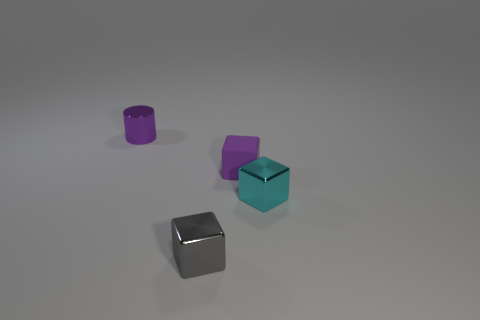Subtract all purple blocks. Subtract all purple cylinders. How many blocks are left? 2 Add 2 large cyan metallic balls. How many objects exist? 6 Subtract all cylinders. How many objects are left? 3 Subtract 0 red cubes. How many objects are left? 4 Subtract all cyan shiny cubes. Subtract all tiny purple blocks. How many objects are left? 2 Add 3 gray things. How many gray things are left? 4 Add 1 tiny purple metal things. How many tiny purple metal things exist? 2 